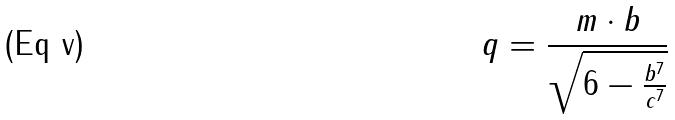Convert formula to latex. <formula><loc_0><loc_0><loc_500><loc_500>q = \frac { m \cdot b } { \sqrt { 6 - \frac { b ^ { 7 } } { c ^ { 7 } } } }</formula> 